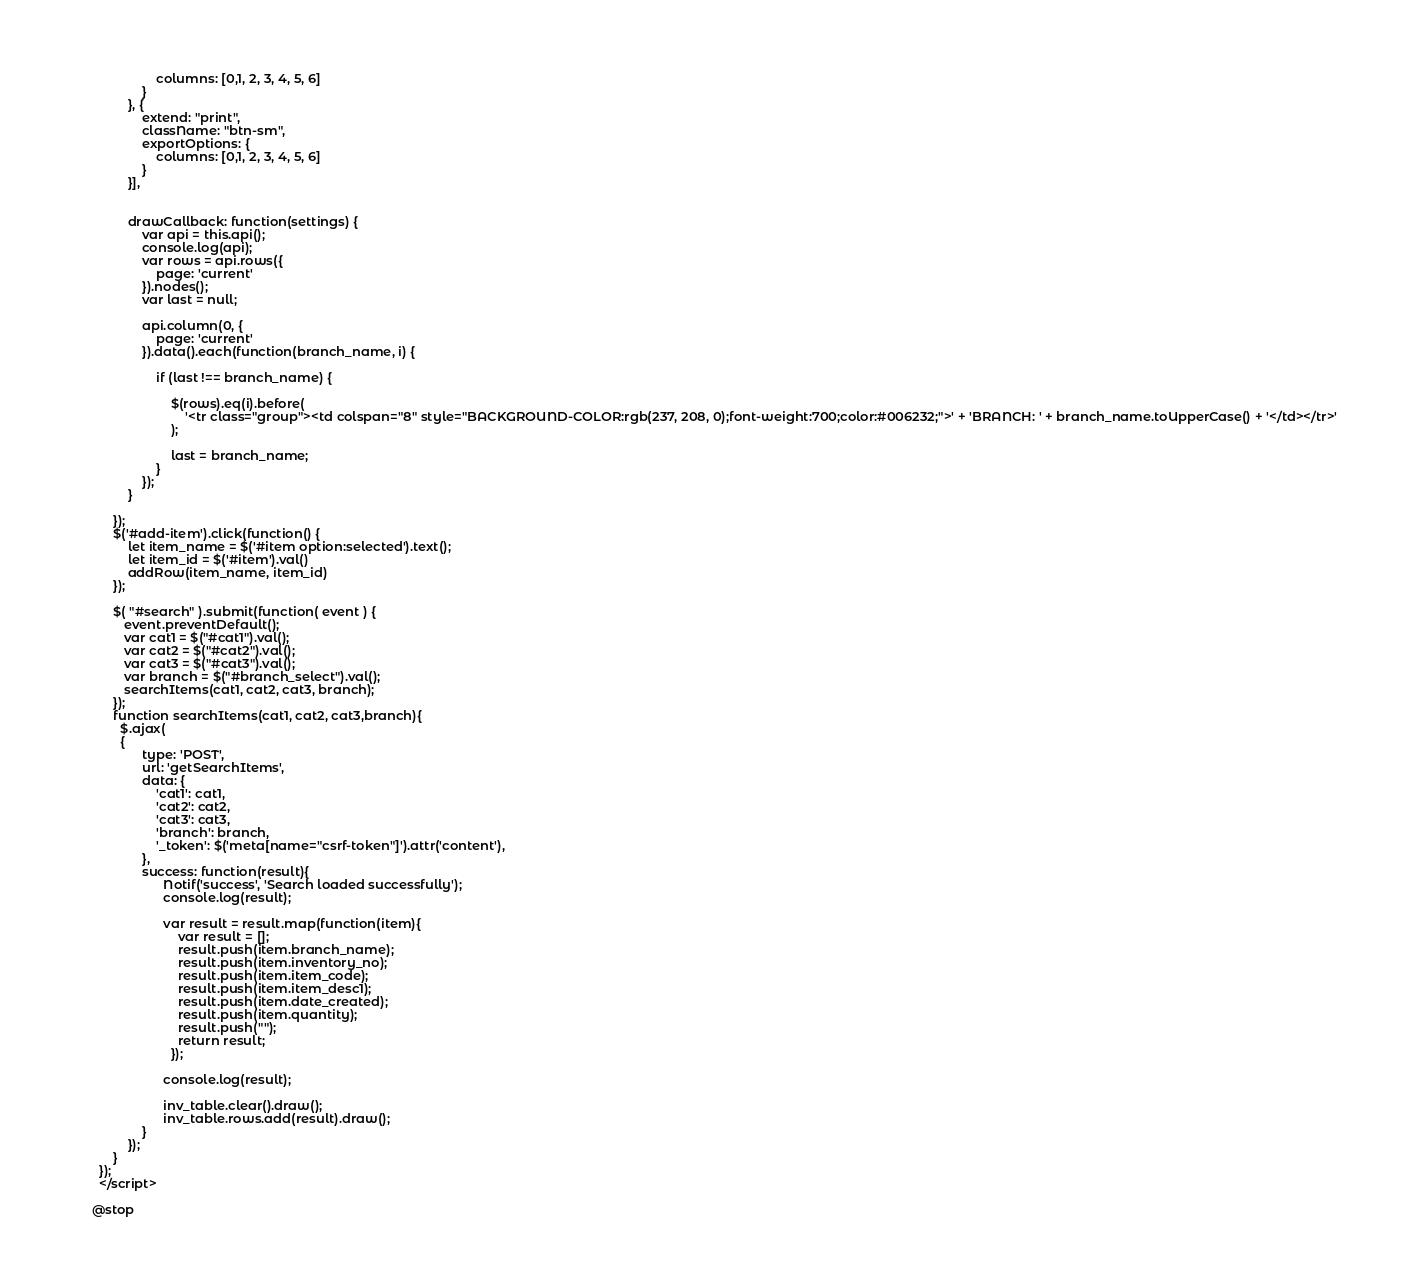<code> <loc_0><loc_0><loc_500><loc_500><_PHP_>                        columns: [0,1, 2, 3, 4, 5, 6]
                    }
                }, {
                    extend: "print",
                    className: "btn-sm",
                    exportOptions: {
                        columns: [0,1, 2, 3, 4, 5, 6]
                    }
                }],


                drawCallback: function(settings) {
                    var api = this.api();
                    console.log(api);
                    var rows = api.rows({
                        page: 'current'
                    }).nodes();
                    var last = null;

                    api.column(0, {
                        page: 'current'
                    }).data().each(function(branch_name, i) {

                        if (last !== branch_name) {

                            $(rows).eq(i).before(
                                '<tr class="group"><td colspan="8" style="BACKGROUND-COLOR:rgb(237, 208, 0);font-weight:700;color:#006232;">' + 'BRANCH: ' + branch_name.toUpperCase() + '</td></tr>'
                            );

                            last = branch_name;
                        }
                    });
                }

            });
            $('#add-item').click(function() {
                let item_name = $('#item option:selected').text();
                let item_id = $('#item').val()
                addRow(item_name, item_id)
            });

            $( "#search" ).submit(function( event ) {
               event.preventDefault();
               var cat1 = $("#cat1").val(); 
               var cat2 = $("#cat2").val(); 
               var cat3 = $("#cat3").val(); 
               var branch = $("#branch_select").val();
               searchItems(cat1, cat2, cat3, branch);
            });
            function searchItems(cat1, cat2, cat3,branch){
              $.ajax(
              {
                    type: 'POST',
                    url: 'getSearchItems',
                    data: {
                        'cat1': cat1,
                        'cat2': cat2,
                        'cat3': cat3,
                        'branch': branch,
                        '_token': $('meta[name="csrf-token"]').attr('content'),
                    },
                    success: function(result){
                          Notif('success', 'Search loaded successfully');
                          console.log(result);
                      
                          var result = result.map(function(item){
                              var result = [];
                              result.push(item.branch_name);
                              result.push(item.inventory_no); 
                              result.push(item.item_code); 
                              result.push(item.item_desc1); 
                              result.push(item.date_created); 
                              result.push(item.quantity); 
                              result.push(""); 
                              return result;
                            });

                          console.log(result);
                          
                          inv_table.clear().draw();
                          inv_table.rows.add(result).draw();
                    }
                });
            }
        });
        </script>

      @stop</code> 